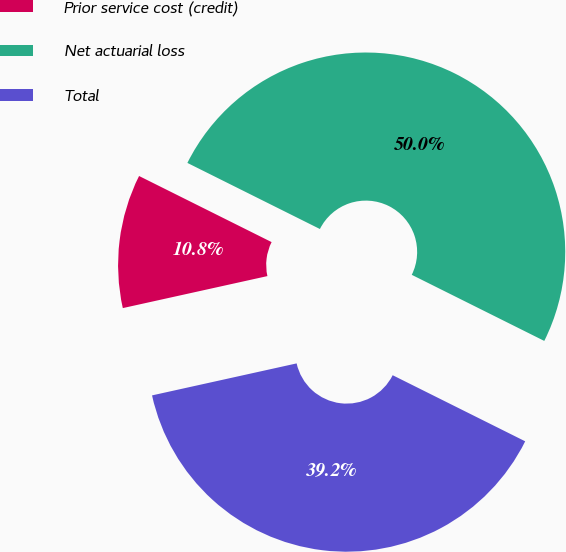Convert chart to OTSL. <chart><loc_0><loc_0><loc_500><loc_500><pie_chart><fcel>Prior service cost (credit)<fcel>Net actuarial loss<fcel>Total<nl><fcel>10.83%<fcel>50.0%<fcel>39.17%<nl></chart> 